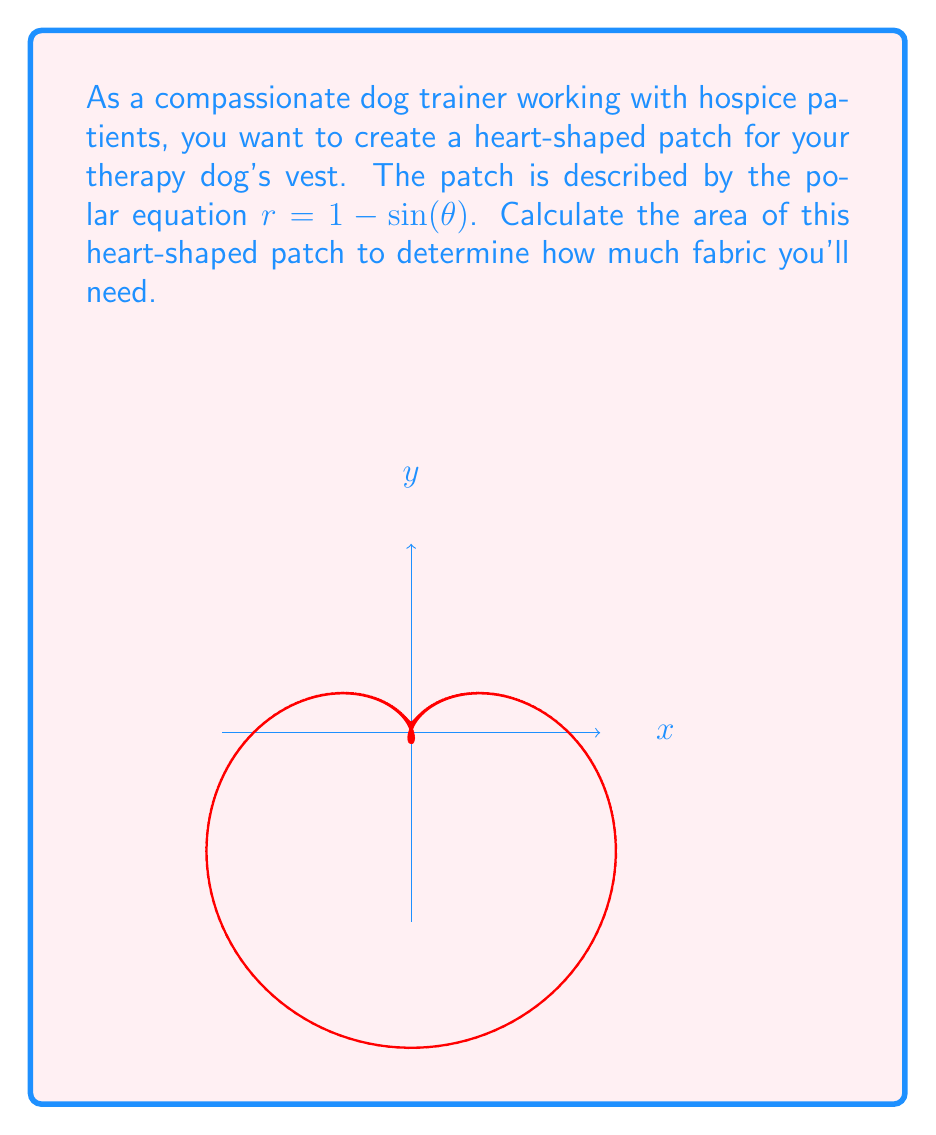Can you answer this question? To calculate the area of the heart-shaped curve, we'll use the formula for area in polar coordinates:

$$A = \frac{1}{2} \int_0^{2\pi} r^2 d\theta$$

1) First, we square the given equation:
   $r^2 = (1 - \sin(\theta))^2 = 1 - 2\sin(\theta) + \sin^2(\theta)$

2) Now, we set up the integral:
   $$A = \frac{1}{2} \int_0^{2\pi} (1 - 2\sin(\theta) + \sin^2(\theta)) d\theta$$

3) Let's integrate each term:
   $$A = \frac{1}{2} \left[ \theta - 2(-\cos(\theta)) + \frac{\theta}{2} - \frac{\sin(2\theta)}{4} \right]_0^{2\pi}$$

4) Evaluate the integral:
   $$A = \frac{1}{2} \left[ (2\pi - 0) - 2(-\cos(2\pi) + \cos(0)) + (\pi - 0) - (\frac{\sin(4\pi)}{4} - \frac{\sin(0)}{4}) \right]$$

5) Simplify:
   $$A = \frac{1}{2} [2\pi - 2(0) + \pi - 0] = \frac{3\pi}{2}$$

Therefore, the area of the heart-shaped patch is $\frac{3\pi}{2}$ square units.
Answer: $\frac{3\pi}{2}$ square units 